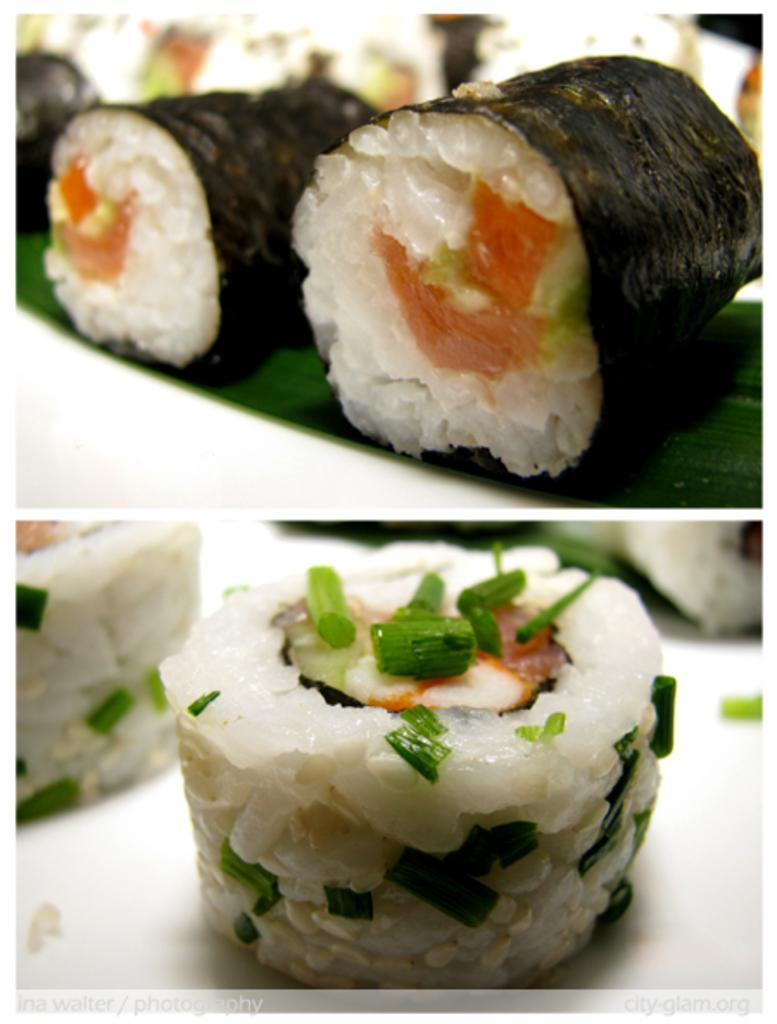How would you summarize this image in a sentence or two? This is a collage picture. Here we can see food. 